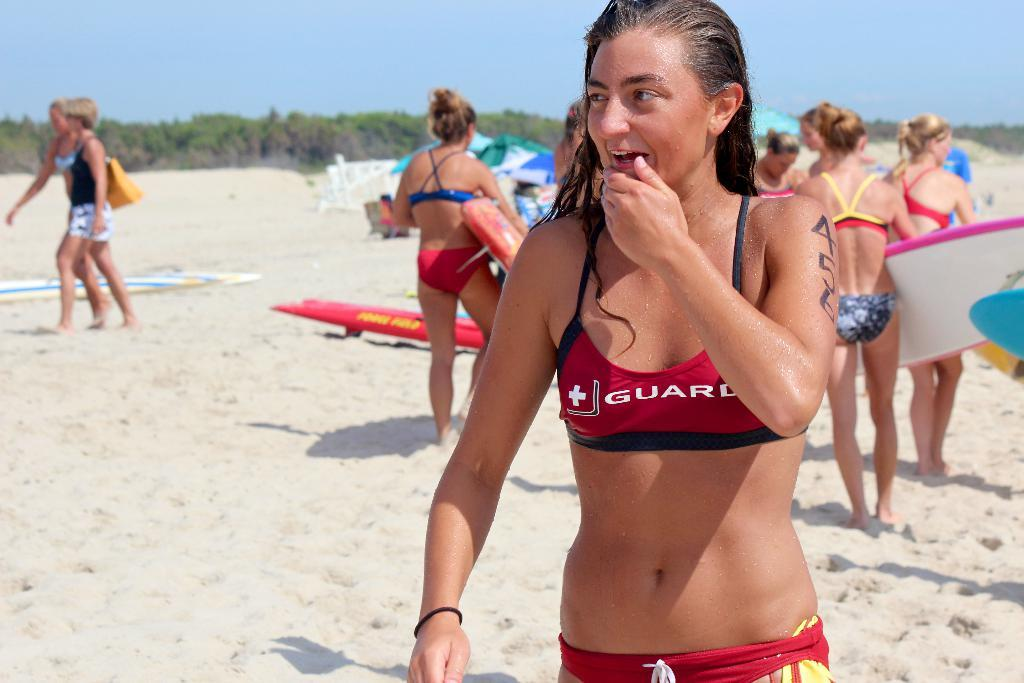<image>
Summarize the visual content of the image. A lifeguard on a beach rubbing her chin. 